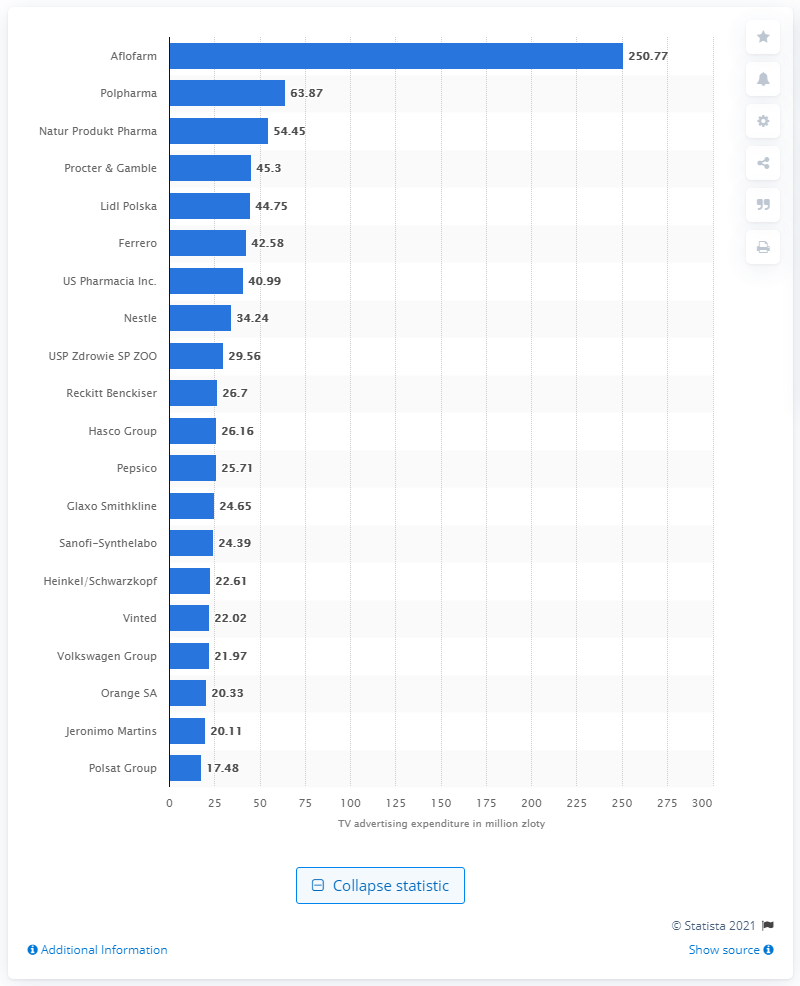Outline some significant characteristics in this image. Aflofarm spent 250.77 on TV expenditures in January 2021. 